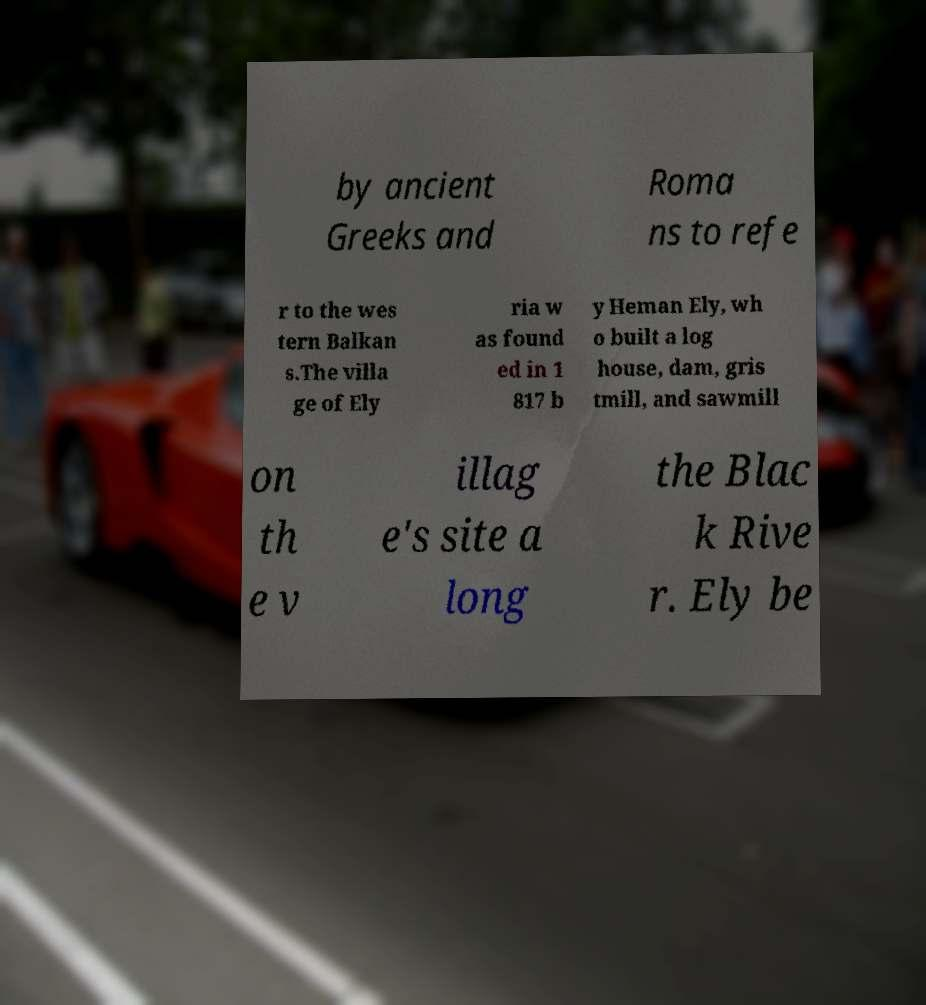What messages or text are displayed in this image? I need them in a readable, typed format. by ancient Greeks and Roma ns to refe r to the wes tern Balkan s.The villa ge of Ely ria w as found ed in 1 817 b y Heman Ely, wh o built a log house, dam, gris tmill, and sawmill on th e v illag e's site a long the Blac k Rive r. Ely be 